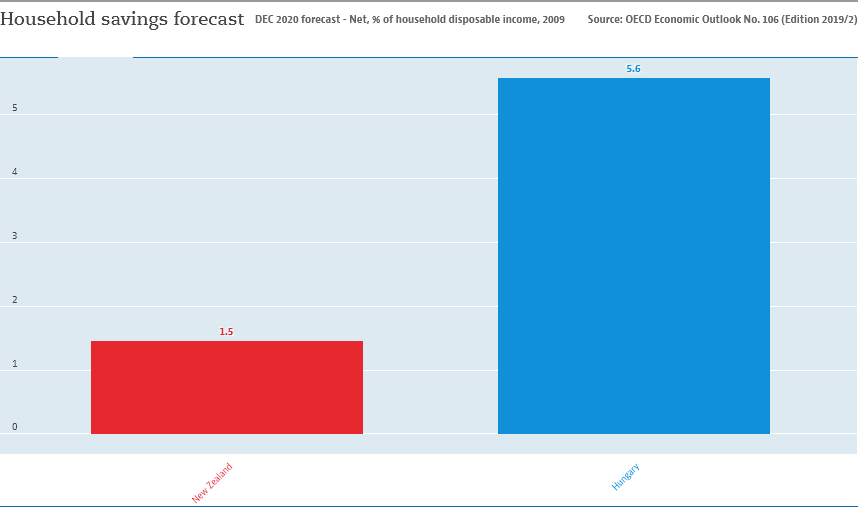Give some essential details in this illustration. The value in Hungary is 5.6... If New Zealand is represented by a color, it would be red. 